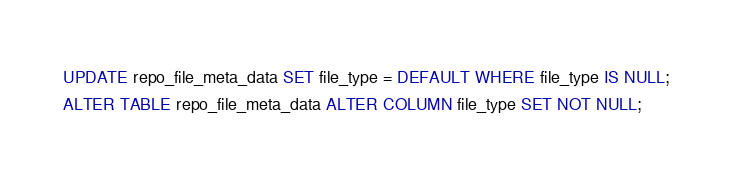<code> <loc_0><loc_0><loc_500><loc_500><_SQL_>UPDATE repo_file_meta_data SET file_type = DEFAULT WHERE file_type IS NULL;
ALTER TABLE repo_file_meta_data ALTER COLUMN file_type SET NOT NULL;
</code> 